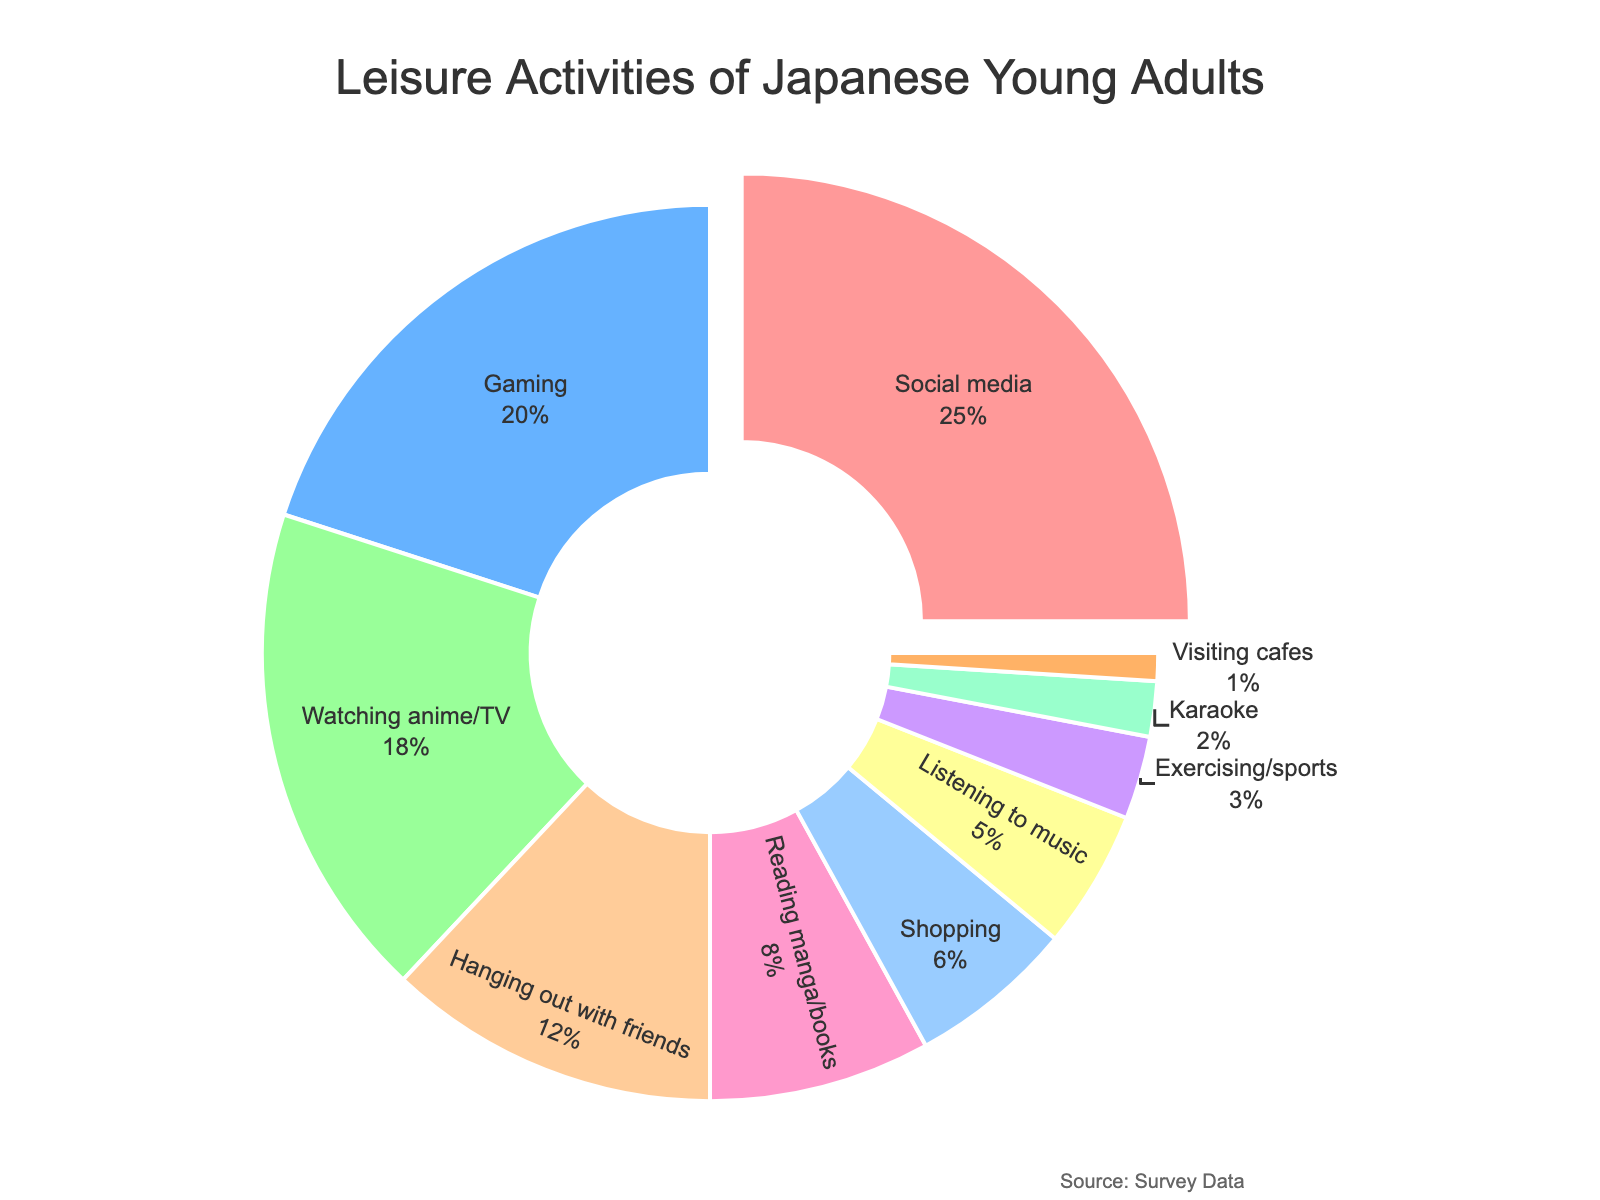What activity has the highest percentage of time spent? The activity with the largest slice in the pie chart and a value pickout is "Social media".
Answer: Social media Which activities have a percentage higher than 10%? Activities with more than 10% are those with larger slices in the pie: "Social media", "Gaming", "Watching anime/TV", and "Hanging out with friends".
Answer: Social media, Gaming, Watching anime/TV, Hanging out with friends What is the total percentage of time spent on Shopping, Exercising/sports, and Karaoke combined? Add the percentages for Shopping (6%), Exercising/sports (3%), and Karaoke (2%) together to get the total: 6 + 3 + 2 = 11.
Answer: 11 Is the percentage of time spent on Listening to music greater than that of Visiting cafes? Listening to music has a percentage of 5%, while Visiting cafes has 1%. Since 5 is greater than 1, the answer is yes.
Answer: Yes What percentage of time is spent on activities other than Social media and Gaming? Subtract the percentage of Social media (25%) and Gaming (20%) from 100%: 100 - 25 - 20 = 55.
Answer: 55 Which activity has the smallest percentage of time spent? The activity with the smallest slice in the pie chart is "Visiting cafes", with a percentage of 1%.
Answer: Visiting cafes How much more percentage is spent on Gaming compared to Reading manga/books? Calculate the difference between Gaming (20%) and Reading manga/books (8%): 20 - 8 = 12.
Answer: 12 Among Reading manga/books, Shopping, and Exercising/sports, which has the highest percentage of time spent? Compare the percentages: Reading manga/books (8%), Shopping (6%), and Exercising/sports (3%). Reading manga/books has the highest percentage.
Answer: Reading manga/books What is the average percentage of time spent on Social media, Gaming, Watching anime/TV, and Hanging out with friends? Sum the percentages and divide by 4: (25 + 20 + 18 + 12) / 4 = 75 / 4 = 18.75.
Answer: 18.75 Which activities together make up exactly half of the total percentage? Adding the percentages: Social media (25%) and Gaming (20%) together give 45%, Social media (25%) and Watching anime/TV (18%) together make 43%, Gaming (20%) and Watching anime/TV (18%) and Hanging out with friends (12%) together make 50%.
Answer: Gaming, Watching anime/TV, Hanging out with friends 